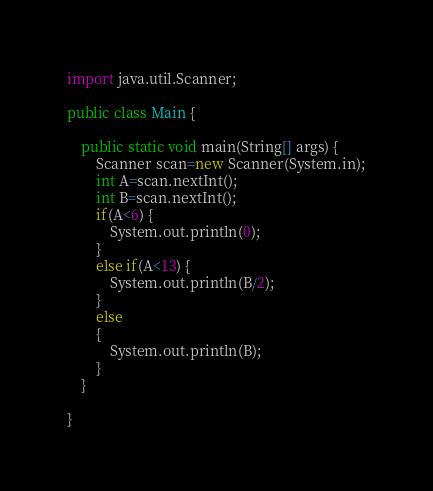Convert code to text. <code><loc_0><loc_0><loc_500><loc_500><_Java_>
import java.util.Scanner;

public class Main {

	public static void main(String[] args) {
		Scanner scan=new Scanner(System.in);
		int A=scan.nextInt();
		int B=scan.nextInt();
		if(A<6) {
			System.out.println(0);
		}
		else if(A<13) {
			System.out.println(B/2);
		}
		else 
		{
			System.out.println(B);
		}
	}

}</code> 